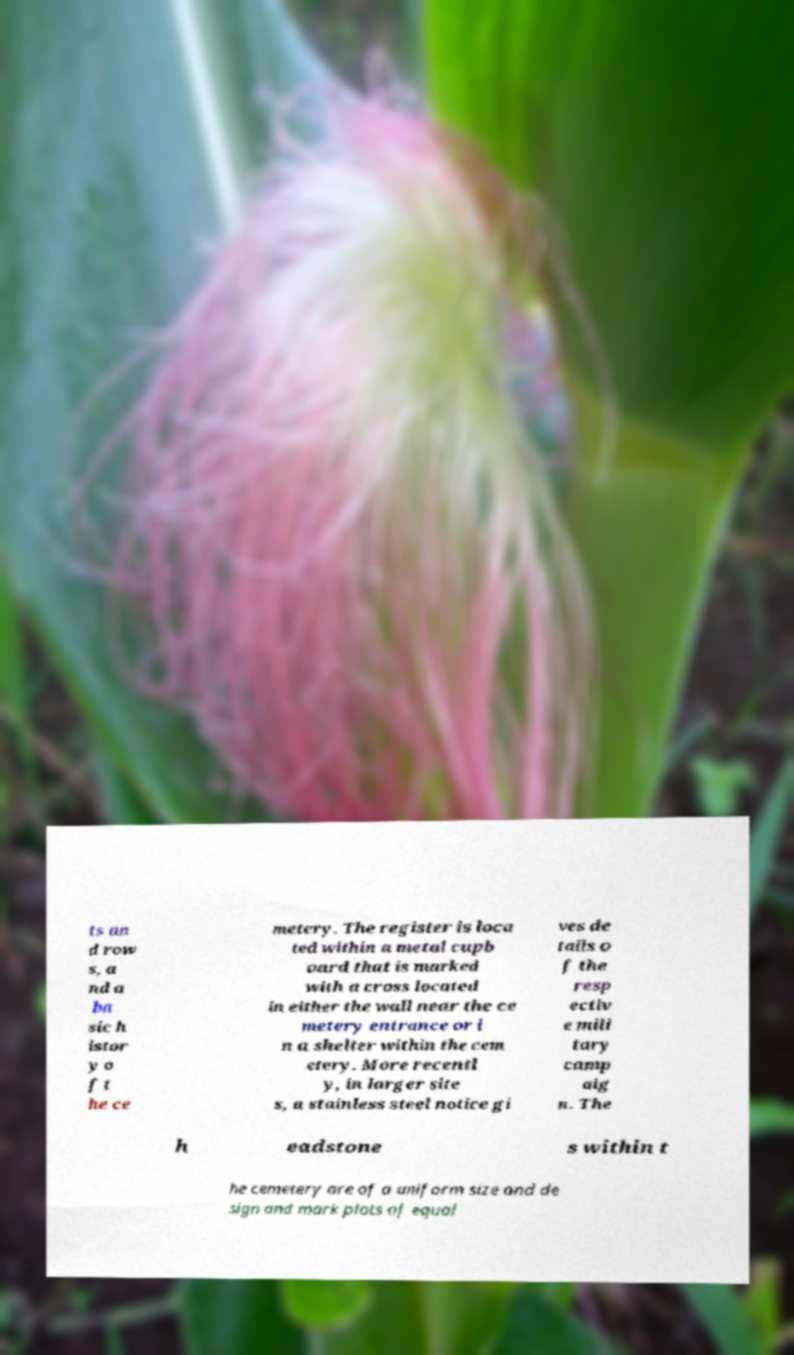Please read and relay the text visible in this image. What does it say? ts an d row s, a nd a ba sic h istor y o f t he ce metery. The register is loca ted within a metal cupb oard that is marked with a cross located in either the wall near the ce metery entrance or i n a shelter within the cem etery. More recentl y, in larger site s, a stainless steel notice gi ves de tails o f the resp ectiv e mili tary camp aig n. The h eadstone s within t he cemetery are of a uniform size and de sign and mark plots of equal 